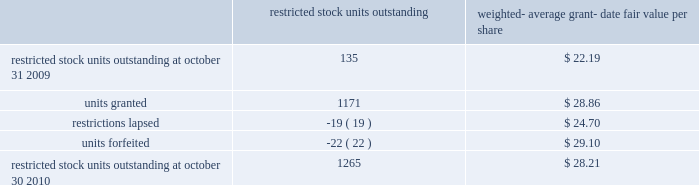Of these options during fiscal 2010 , fiscal 2009 and fiscal 2008 was $ 240.4 million , $ 15.1 million and $ 100.6 mil- lion , respectively .
The total grant-date fair value of stock options that vested during fiscal 2010 , fiscal 2009 and fiscal 2008 was approximately $ 67.2 million , $ 73.6 million and $ 77.6 million , respectively .
Proceeds from stock option exercises pursuant to employee stock plans in the company 2019s statement of cash flows of $ 216.1 million , $ 12.4 million and $ 94.2 million for fiscal 2010 , fiscal 2009 and fiscal 2008 , respectively , are net of the value of shares surrendered by employees in certain limited circumstances to satisfy the exercise price of options , and to satisfy employee tax obligations upon vesting of restricted stock or restricted stock units and in connection with the exercise of stock options granted to the company 2019s employees under the company 2019s equity compensation plans .
The withholding amount is based on the company 2019s minimum statutory withholding requirement .
A summary of the company 2019s restricted stock unit award activity as of october 30 , 2010 and changes during the year then ended is presented below : restricted outstanding weighted- average grant- date fair value per share .
As of october 30 , 2010 there was $ 95 million of total unrecognized compensation cost related to unvested share-based awards comprised of stock options and restricted stock units .
That cost is expected to be recognized over a weighted-average period of 1.4 years .
Common stock repurchase program the company 2019s common stock repurchase program has been in place since august 2004 .
In the aggregate , the board of directors has authorized the company to repurchase $ 4 billion of the company 2019s common stock under the program .
Under the program , the company may repurchase outstanding shares of its common stock from time to time in the open market and through privately negotiated transactions .
Unless terminated earlier by resolution of the company 2019s board of directors , the repurchase program will expire when the company has repurchased all shares authorized under the program .
As of october 30 , 2010 , the company had repurchased a total of approximately 116.0 million shares of its common stock for approximately $ 3948.2 million under this program .
An additional $ 51.8 million remains available for repurchase of shares under the current authorized program .
The repurchased shares are held as authorized but unissued shares of common stock .
Any future common stock repurchases will be dependent upon several factors including the amount of cash available to the company in the united states , and the company 2019s financial performance , outlook and liquidity .
The company also from time to time repurchases shares in settlement of employee tax withholding obligations due upon the vesting of restricted stock or restricted stock units , or in certain limited circumstances to satisfy the exercise price of options granted to the company 2019s employees under the company 2019s equity compensation plans .
Preferred stock the company has 471934 authorized shares of $ 1.00 par value preferred stock , none of which is issued or outstanding .
The board of directors is authorized to fix designations , relative rights , preferences and limitations on the preferred stock at the time of issuance .
Analog devices , inc .
Notes to consolidated financial statements 2014 ( continued ) .
What is the average-share price of the repurchased shares as of october 30 , 2010? 
Computations: (3948.2 / 116.0)
Answer: 34.03621. 